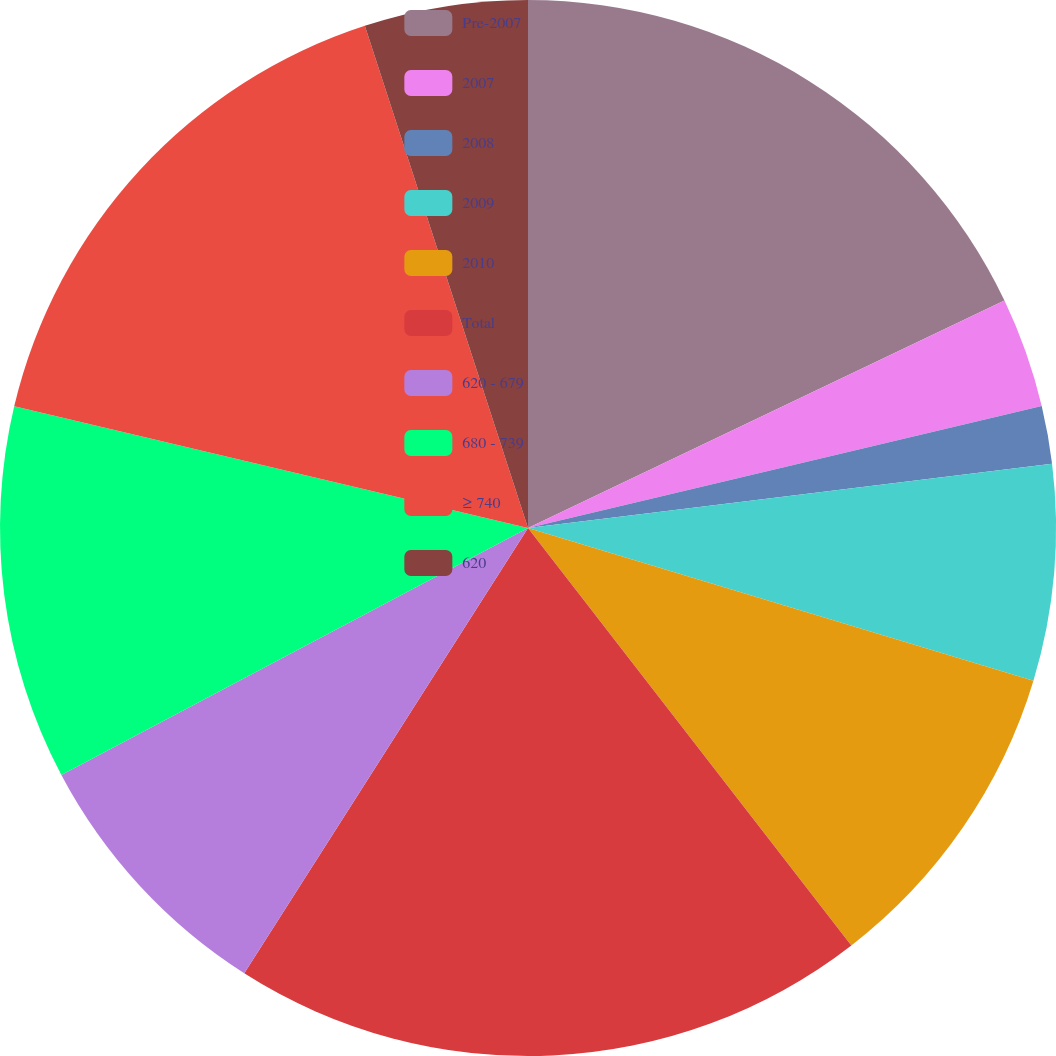Convert chart. <chart><loc_0><loc_0><loc_500><loc_500><pie_chart><fcel>Pre-2007<fcel>2007<fcel>2008<fcel>2009<fcel>2010<fcel>Total<fcel>620 - 679<fcel>680 - 739<fcel>≥ 740<fcel>620<nl><fcel>17.91%<fcel>3.38%<fcel>1.77%<fcel>6.61%<fcel>9.84%<fcel>19.52%<fcel>8.22%<fcel>11.45%<fcel>16.3%<fcel>5.0%<nl></chart> 